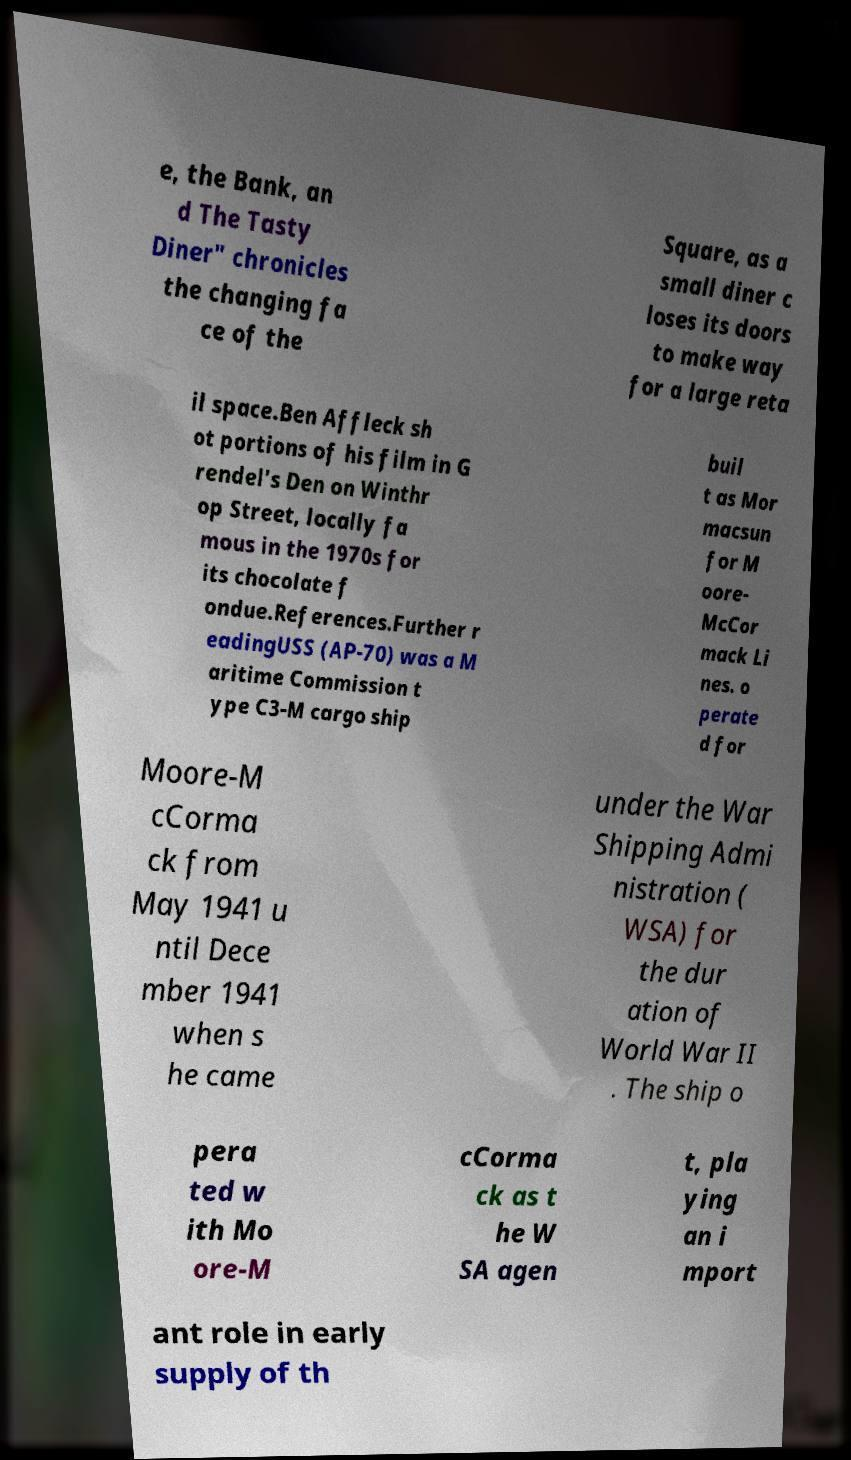For documentation purposes, I need the text within this image transcribed. Could you provide that? e, the Bank, an d The Tasty Diner" chronicles the changing fa ce of the Square, as a small diner c loses its doors to make way for a large reta il space.Ben Affleck sh ot portions of his film in G rendel's Den on Winthr op Street, locally fa mous in the 1970s for its chocolate f ondue.References.Further r eadingUSS (AP-70) was a M aritime Commission t ype C3-M cargo ship buil t as Mor macsun for M oore- McCor mack Li nes. o perate d for Moore-M cCorma ck from May 1941 u ntil Dece mber 1941 when s he came under the War Shipping Admi nistration ( WSA) for the dur ation of World War II . The ship o pera ted w ith Mo ore-M cCorma ck as t he W SA agen t, pla ying an i mport ant role in early supply of th 